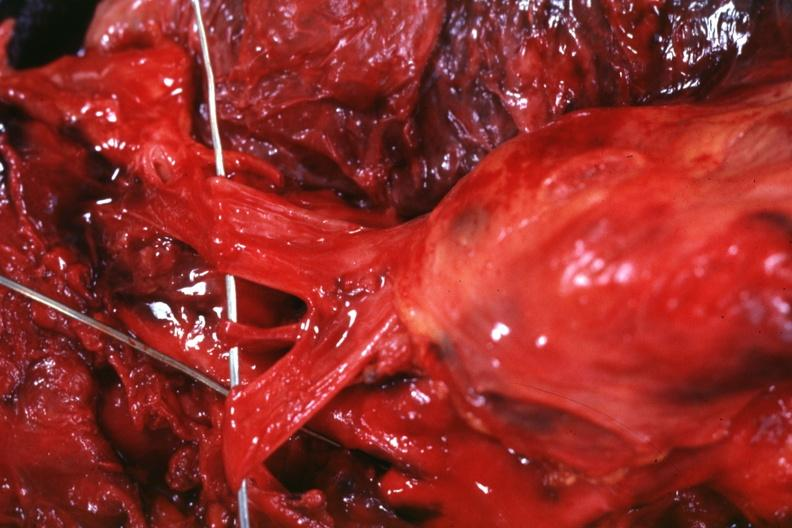s the superior vena cava invaded by the tumor?
Answer the question using a single word or phrase. Yes 